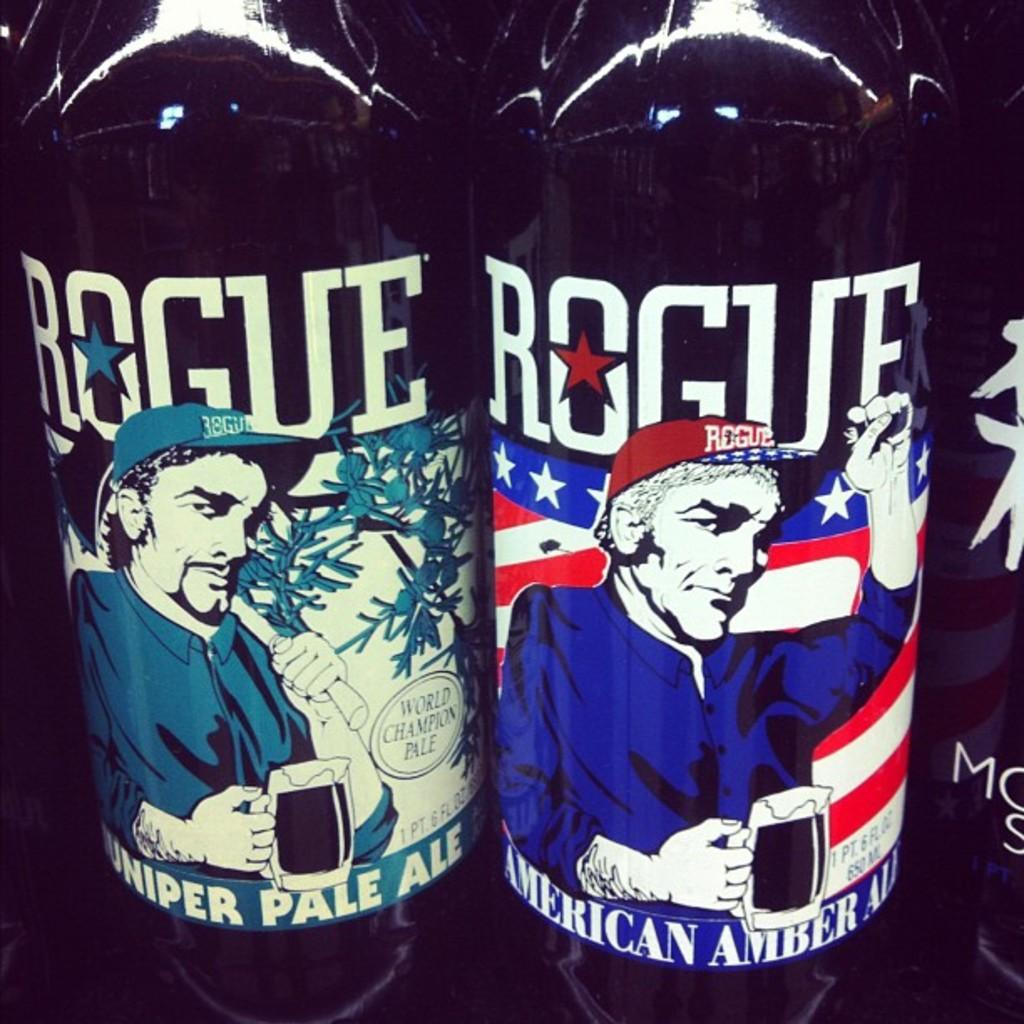<image>
Provide a brief description of the given image. some bottles that have the words rogue on them 